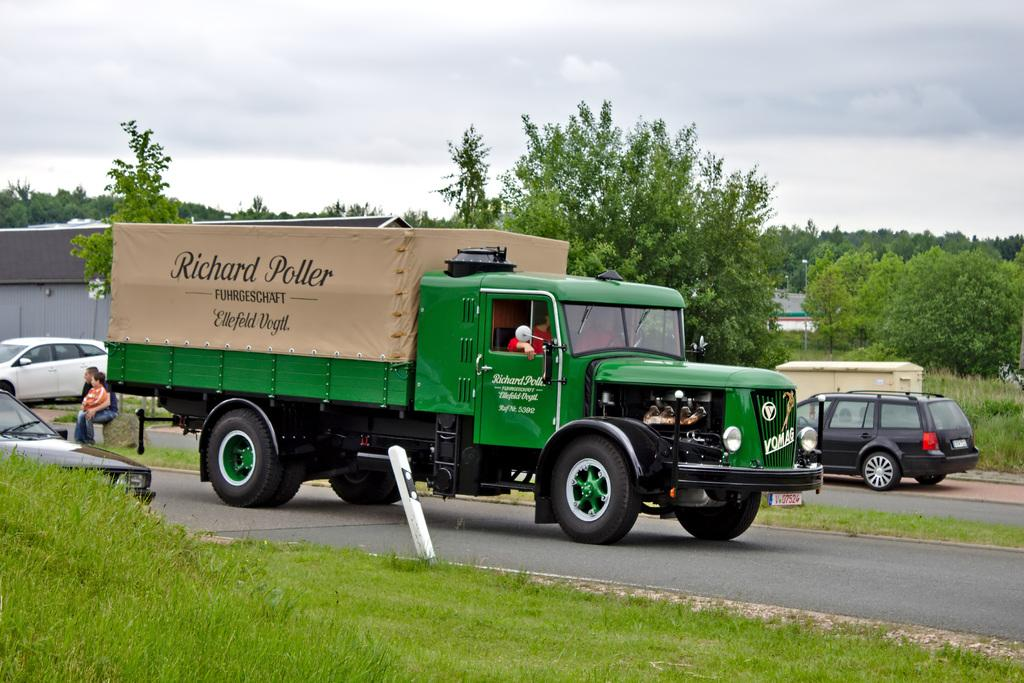What type of vehicle is in the image? There is a green color truck in the image. Where is the truck located? The truck is on the road. What else can be seen on the road in the image? There are cars moving on the road. What can be seen in the background of the image? There are trees and clouds in the sky in the background of the image. What type of stew is being served at the truck stop in the image? There is no indication of a truck stop or any food being served in the image. 